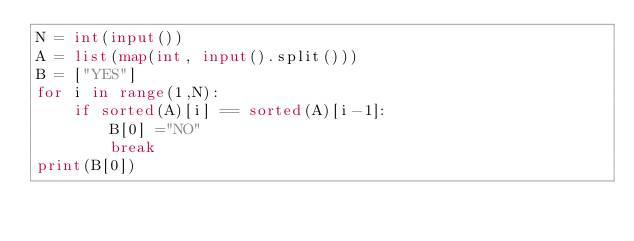Convert code to text. <code><loc_0><loc_0><loc_500><loc_500><_Python_>N = int(input())
A = list(map(int, input().split()))
B = ["YES"]
for i in range(1,N):
    if sorted(A)[i] == sorted(A)[i-1]:
        B[0] ="NO"
        break
print(B[0])</code> 